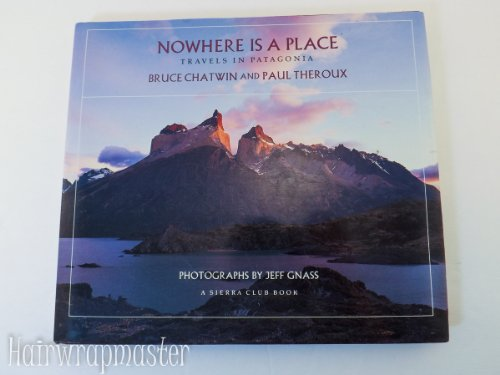Who took the photographs for this book, and what is their significance? The photographs in this book were taken by Jeff Gnass, who is known for his ability to capture the natural beauty and essence of remote landscapes. His work adds a visual depth to the narrative, allowing readers to visually engage with the diverse scenery and mood of Patagonia as described by the authors. 